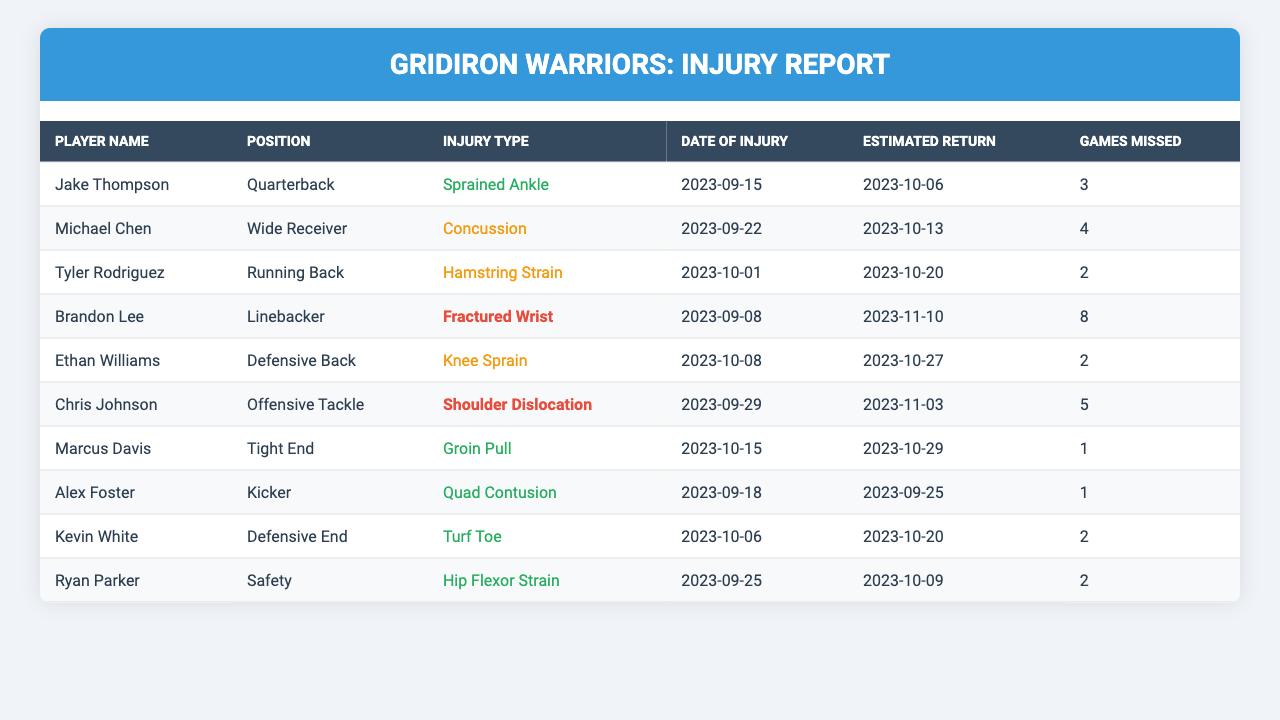What is the injury type for Jake Thompson? In the table under the column "Player Name," if we look for Jake Thompson, we can see that his corresponding "Injury Type" is listed as "Sprained Ankle."
Answer: Sprained Ankle How many games has Brandon Lee missed? In the row for Brandon Lee, the "Games Missed" column shows the value 8.
Answer: 8 Which player has the smallest estimated return time? To identify the smallest estimated return time, we check the "Estimated Return" dates for all players. Marcus Davis is set to return on 2023-10-29, which is sooner than all others.
Answer: Marcus Davis Is Kevin White's injury type classified as high, medium, or low? Looking at Kevin White's "Injury Type," which is "Turf Toe," we see that it is not listed among the high or medium injury types, thus it is classified as low.
Answer: Low What is the total number of games missed by all players combined? We sum the "Games Missed" values from each player: 3 + 4 + 2 + 8 + 2 + 5 + 1 + 1 + 2 + 2 = 28.
Answer: 28 Who is expected to return next? By comparing the "Estimated Return" dates, we see that Alex Foster is set to return on 2023-09-25, which is the earliest return date on the list.
Answer: Alex Foster Has any player missed a game due to a knee injury? Checking the "Injury Type" column, we find Ethan Williams with a "Knee Sprain," indicating a game was missed due to a knee injury.
Answer: Yes How many players are classified with medium injuries? By reviewing the "Injury Type" column, the injuries classified as medium are Concussion, Hamstring Strain, and Knee Sprain. In the table, there are 4 players fitting this category: Michael Chen, Tyler Rodriguez, and Ethan Williams.
Answer: 4 What date did Ryan Parker suffer his injury? Looking under the "Date of Injury" column for Ryan Parker, we find that he suffered his injury on 2023-09-25.
Answer: 2023-09-25 Which player has the longest estimated return time? We can determine this by comparing the "Estimated Return" dates. Brandon Lee's estimated return is on 2023-11-10, which is the latest among all listed players.
Answer: Brandon Lee 